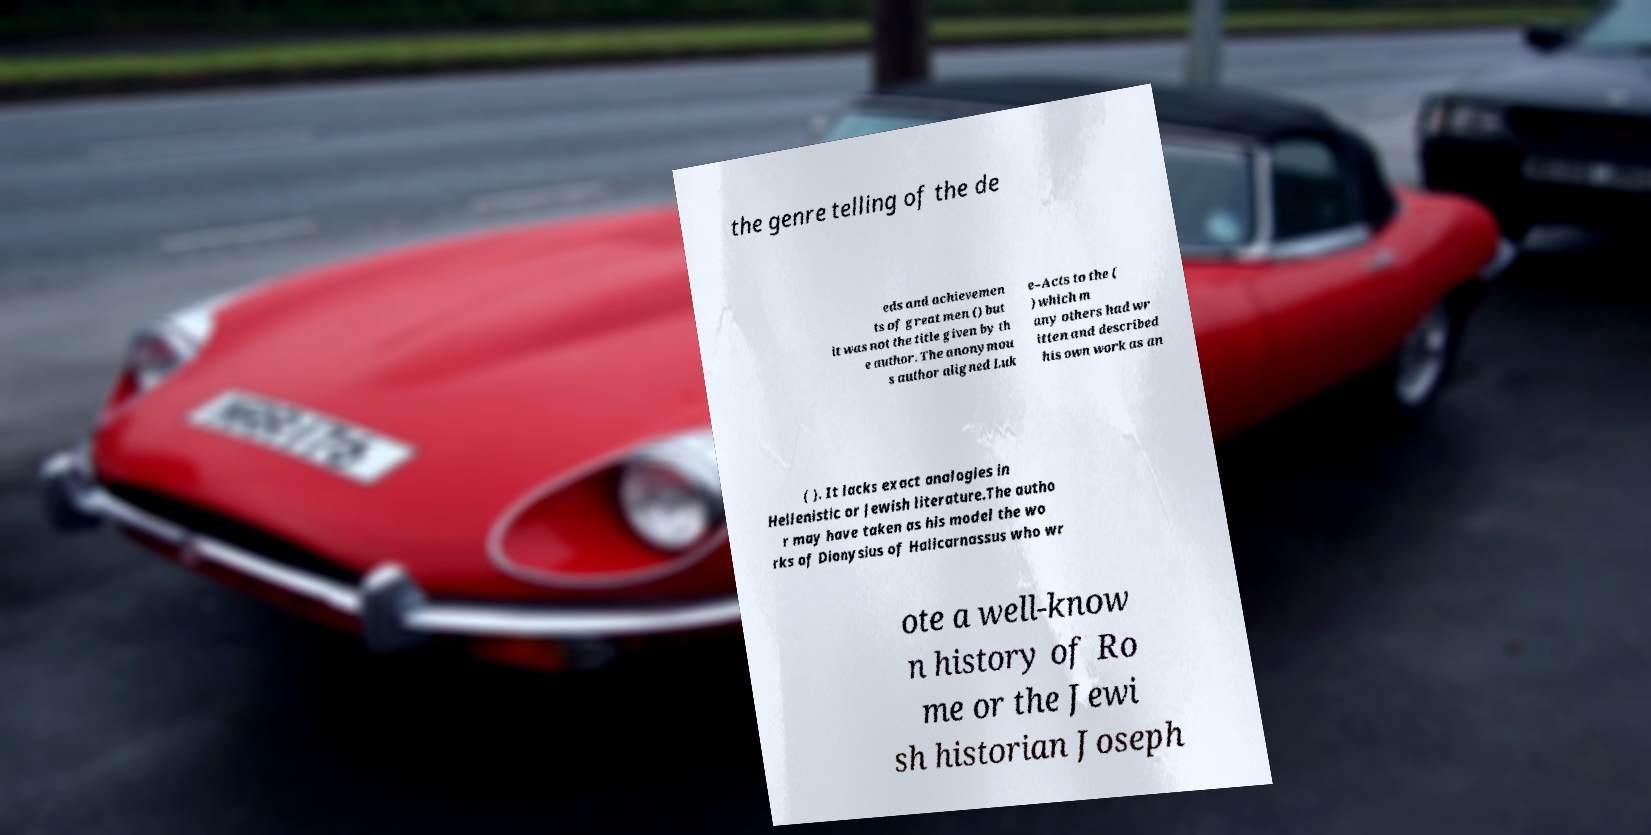There's text embedded in this image that I need extracted. Can you transcribe it verbatim? the genre telling of the de eds and achievemen ts of great men () but it was not the title given by th e author. The anonymou s author aligned Luk e–Acts to the ( ) which m any others had wr itten and described his own work as an ( ). It lacks exact analogies in Hellenistic or Jewish literature.The autho r may have taken as his model the wo rks of Dionysius of Halicarnassus who wr ote a well-know n history of Ro me or the Jewi sh historian Joseph 